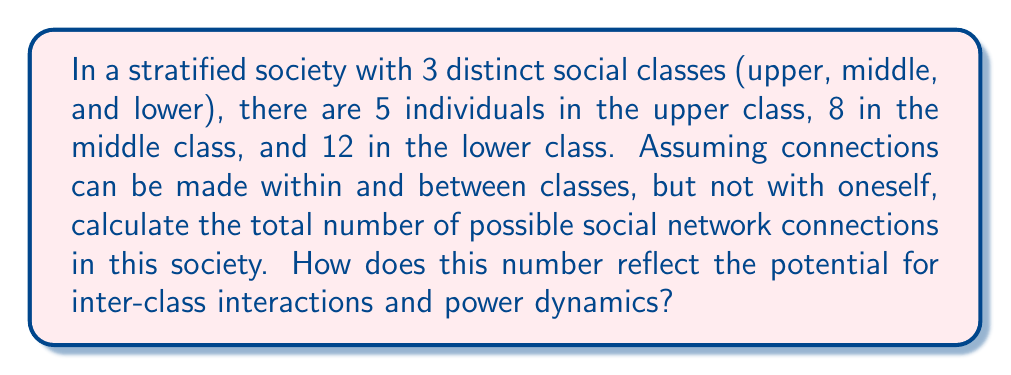Teach me how to tackle this problem. Let's approach this step-by-step:

1) First, let's calculate connections within each class:
   
   Upper class: $\binom{5}{2} = 10$ connections
   Middle class: $\binom{8}{2} = 28$ connections
   Lower class: $\binom{12}{2} = 66$ connections

2) Now, let's calculate connections between classes:
   
   Upper-Middle: $5 \times 8 = 40$ connections
   Upper-Lower: $5 \times 12 = 60$ connections
   Middle-Lower: $8 \times 12 = 96$ connections

3) Total connections:
   $$(10 + 28 + 66) + (40 + 60 + 96) = 104 + 196 = 300$$

4) This can be generalized as:

   $$\sum_{i=1}^{n} \binom{c_i}{2} + \sum_{i=1}^{n-1} \sum_{j=i+1}^{n} c_i c_j$$

   Where $n$ is the number of classes and $c_i$ is the number of individuals in class $i$.

5) The total number of connections (300) represents the maximum potential for social interactions. The distribution of these connections reflects power dynamics:

   - Intra-class connections: 104 (34.67%)
   - Inter-class connections: 196 (65.33%)

6) Despite the lower class having the most members, they have fewer total potential connections (222) compared to the middle class (224) and upper class (210), illustrating how class size doesn't necessarily correlate with social influence.
Answer: 300 connections; 34.67% intra-class, 65.33% inter-class 